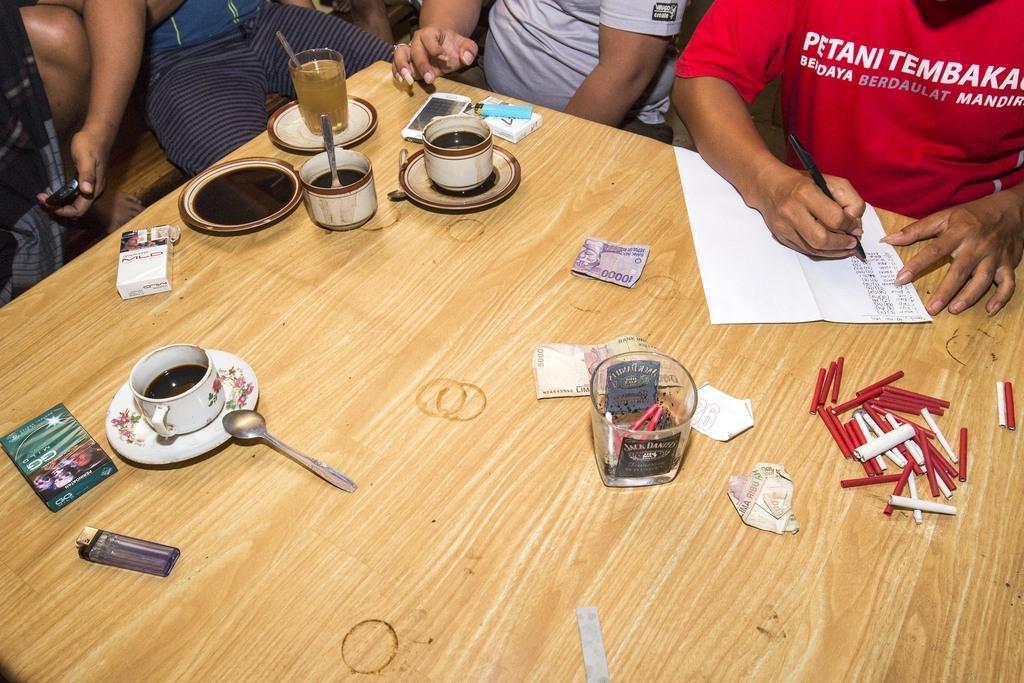How would you summarize this image in a sentence or two? In this image, There is a table which is in yellow color, On that table there are some cups there are some glasses and there are some objects which are in red color, There is a lighter which is in blue color, There are some people sitting around the table. 